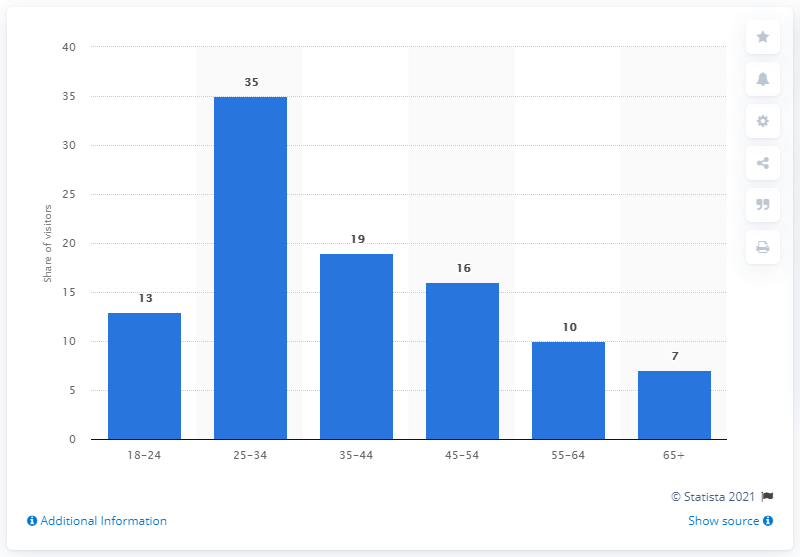Identify some key points in this picture. In the UK in 2019, approximately 19% of visitors to Pornhub.com were between the ages of 35 and 44. 